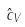<formula> <loc_0><loc_0><loc_500><loc_500>\hat { c } _ { V }</formula> 